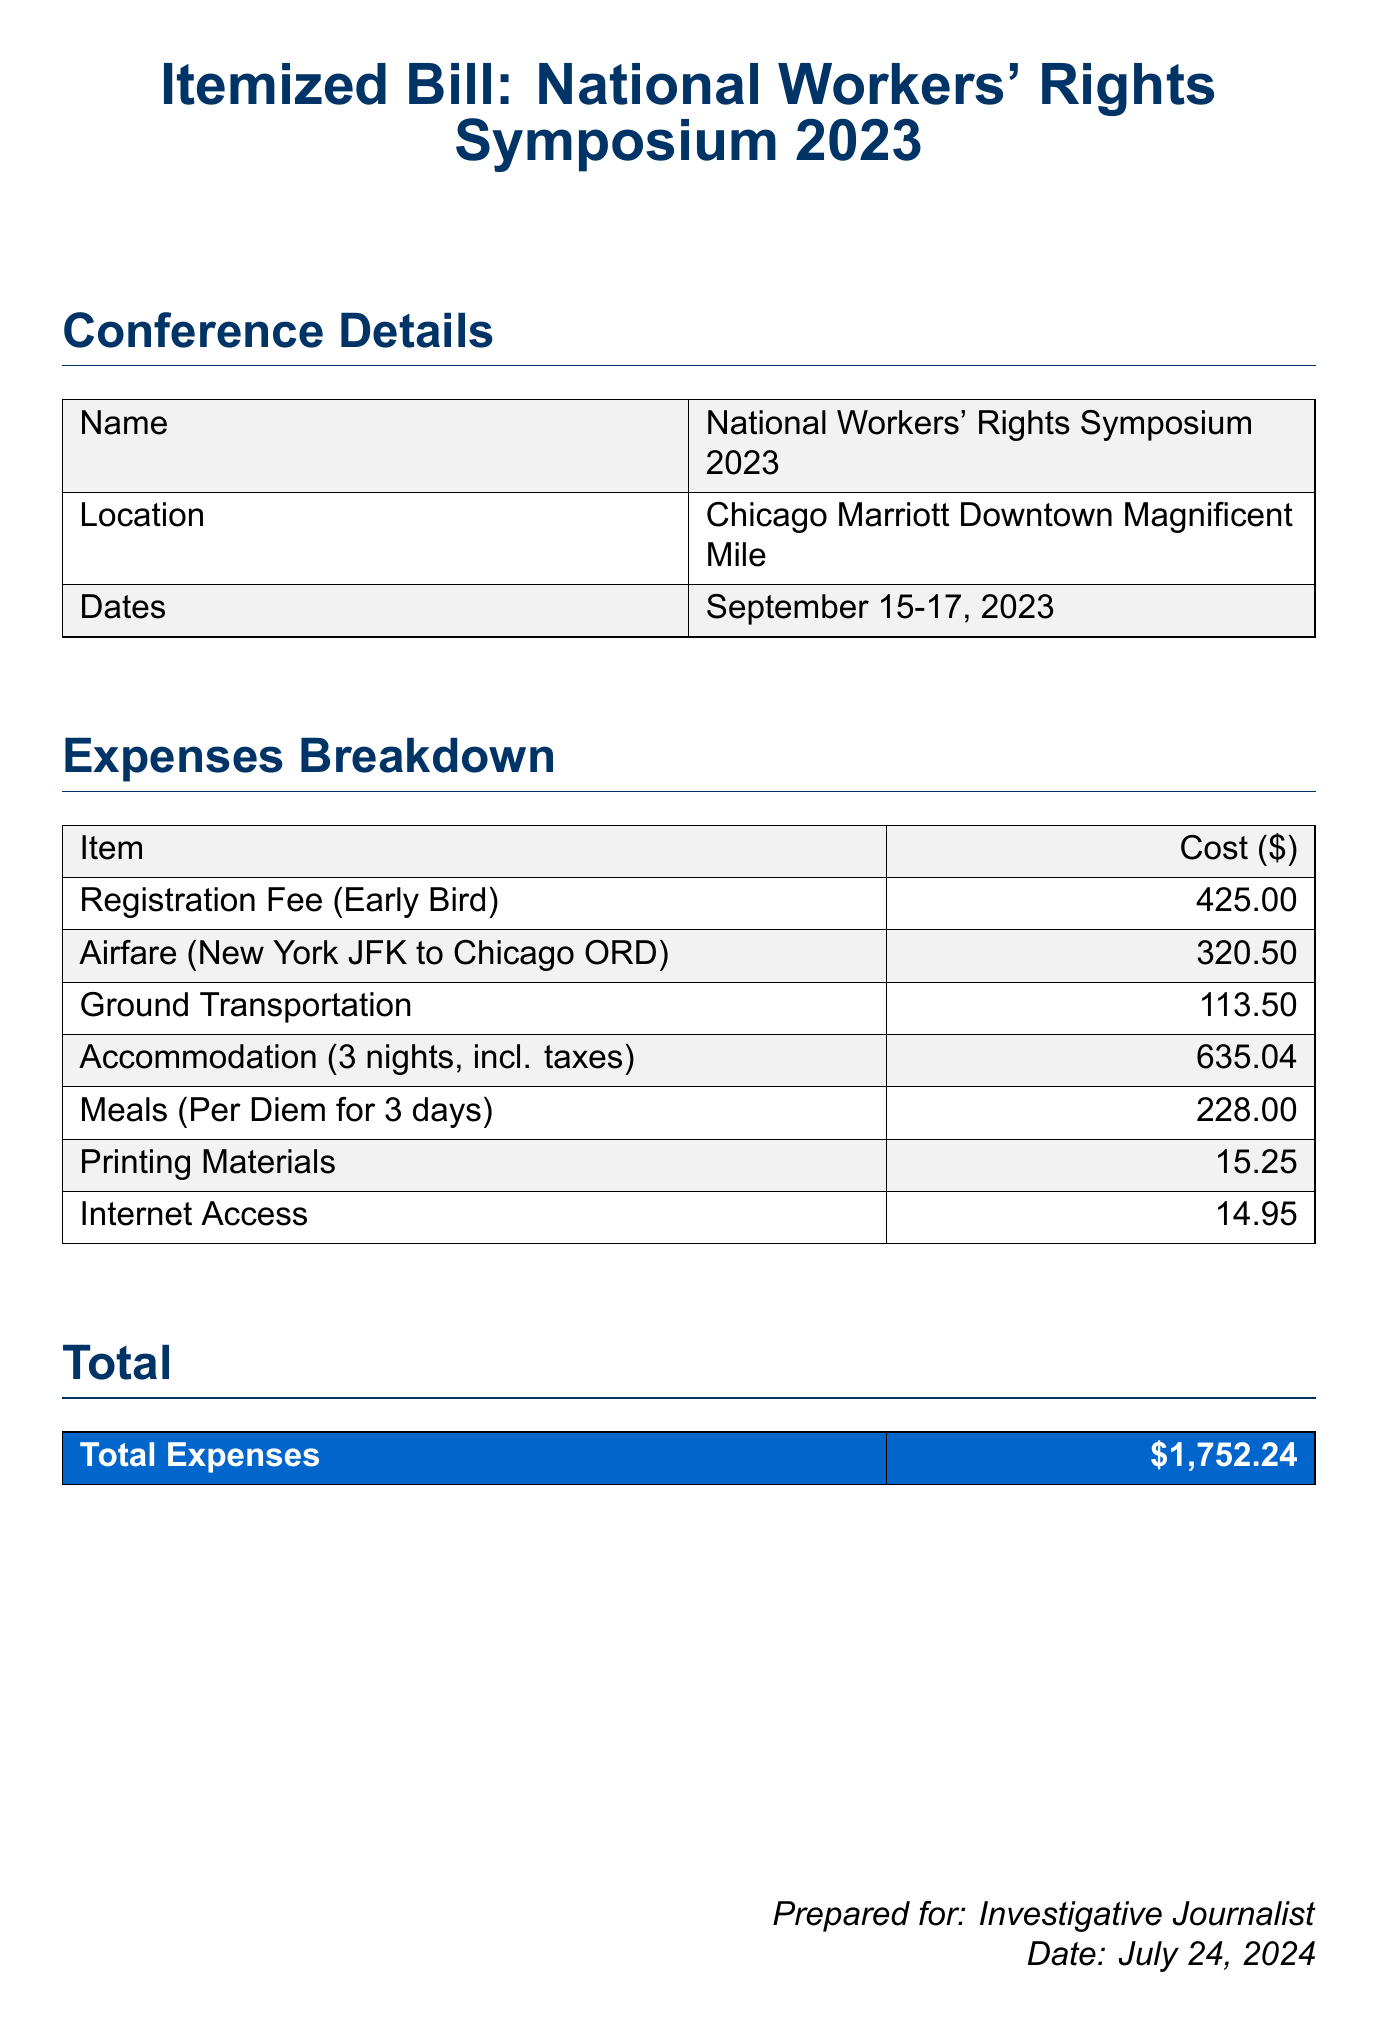What is the location of the conference? The location is specified in the conference details section of the document, which states the conference is at the Chicago Marriott Downtown Magnificent Mile.
Answer: Chicago Marriott Downtown Magnificent Mile What are the dates of the National Workers' Rights Symposium? The dates of the symposium can be found in the conference details section, which lists September 15-17, 2023, as the event dates.
Answer: September 15-17, 2023 What is the cost of the registration fee? The registration fee is detailed under the expenses breakdown, which lists the early bird registration fee as $425.00.
Answer: 425.00 How much did the airfare cost? The airfare cost is listed in the expenses breakdown, showing the amount for travel from New York JFK to Chicago ORD as $320.50.
Answer: 320.50 What was the total expense for accommodation? The accommodation cost is noted in the expenses breakdown, which indicates the total for three nights (including taxes) as $635.04.
Answer: 635.04 What is the total amount of expenses listed? The total expenses are provided in the summary section at the end of the document, which states the total amount is $1,752.24.
Answer: 1,752.24 How many nights of accommodation were charged? The document specifies that the accommodation includes a charge for three nights in the expenses breakdown.
Answer: 3 nights What is included in the meals expense? The meals expense is detailed in the expenses section, which states it covers a per diem for three days amounting to $228.00.
Answer: Per Diem for 3 days What is the cost for printing materials? The cost for printing materials is found in the expenses breakdown, specifically listed as $15.25.
Answer: 15.25 